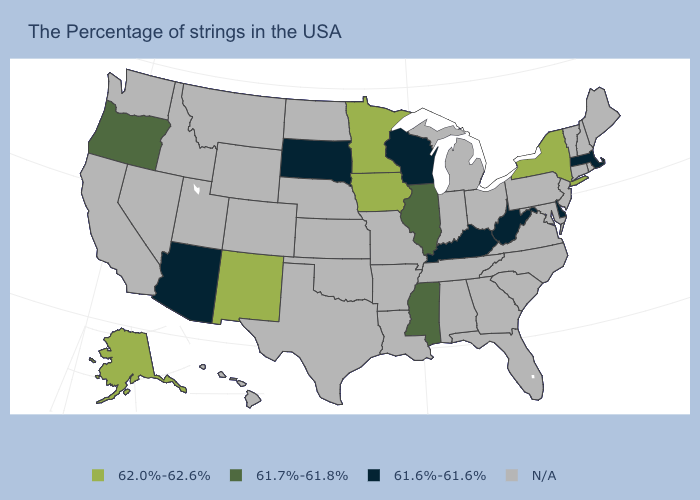What is the highest value in the USA?
Give a very brief answer. 62.0%-62.6%. What is the value of Utah?
Be succinct. N/A. Which states have the highest value in the USA?
Write a very short answer. New York, Minnesota, Iowa, New Mexico, Alaska. Among the states that border Wyoming , which have the lowest value?
Be succinct. South Dakota. Which states hav the highest value in the South?
Give a very brief answer. Mississippi. How many symbols are there in the legend?
Quick response, please. 4. What is the lowest value in states that border Arizona?
Give a very brief answer. 62.0%-62.6%. What is the lowest value in the Northeast?
Answer briefly. 61.6%-61.6%. Does Mississippi have the highest value in the South?
Short answer required. Yes. What is the lowest value in states that border Rhode Island?
Write a very short answer. 61.6%-61.6%. Name the states that have a value in the range 61.6%-61.6%?
Short answer required. Massachusetts, Delaware, West Virginia, Kentucky, Wisconsin, South Dakota, Arizona. Among the states that border Utah , does Arizona have the highest value?
Give a very brief answer. No. What is the highest value in the West ?
Short answer required. 62.0%-62.6%. What is the lowest value in the West?
Keep it brief. 61.6%-61.6%. Does New Mexico have the highest value in the USA?
Quick response, please. Yes. 